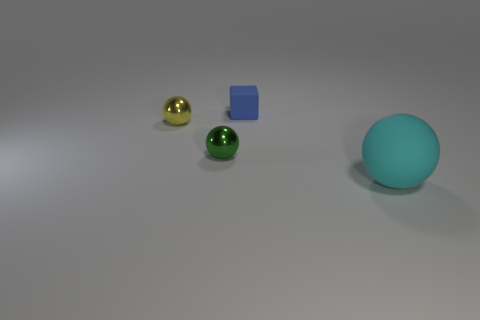Is there a cyan cube of the same size as the green object?
Provide a short and direct response. No. Is the color of the thing that is to the right of the matte block the same as the tiny block?
Offer a very short reply. No. How many yellow objects are spheres or large things?
Your response must be concise. 1. Is the small green object made of the same material as the yellow thing?
Your answer should be very brief. Yes. There is a matte object that is behind the large object; what number of metal objects are on the left side of it?
Offer a very short reply. 2. Is the cyan thing the same size as the yellow shiny object?
Provide a succinct answer. No. How many tiny things have the same material as the cube?
Your answer should be very brief. 0. What size is the cyan thing that is the same shape as the yellow object?
Offer a very short reply. Large. There is a rubber thing on the right side of the blue block; is its shape the same as the tiny green thing?
Your response must be concise. Yes. The matte object that is to the left of the thing on the right side of the cube is what shape?
Make the answer very short. Cube. 